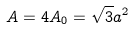<formula> <loc_0><loc_0><loc_500><loc_500>A = 4 A _ { 0 } = \sqrt { 3 } a ^ { 2 }</formula> 